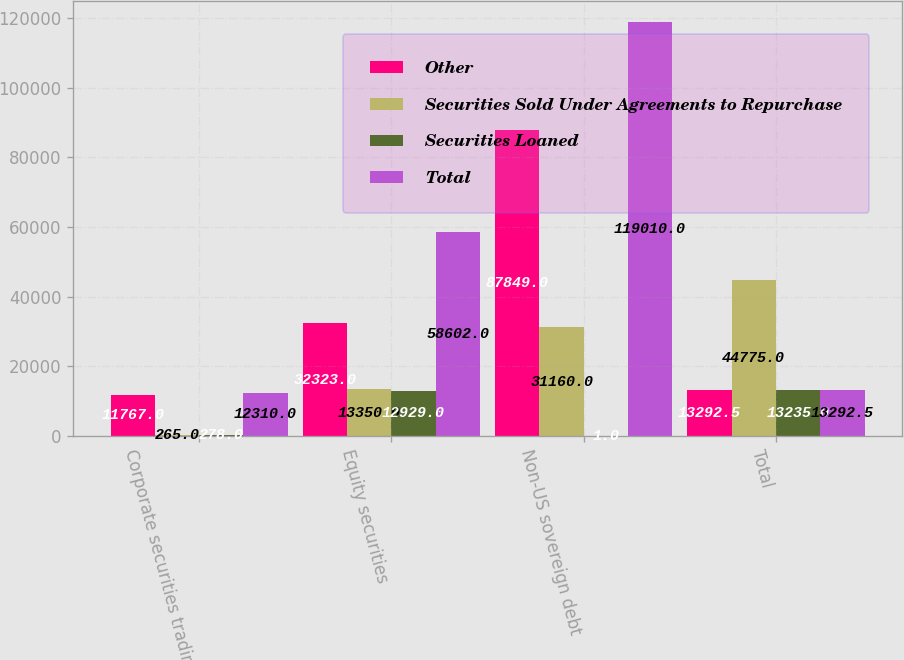Convert chart to OTSL. <chart><loc_0><loc_0><loc_500><loc_500><stacked_bar_chart><ecel><fcel>Corporate securities trading<fcel>Equity securities<fcel>Non-US sovereign debt<fcel>Total<nl><fcel>Other<fcel>11767<fcel>32323<fcel>87849<fcel>13292.5<nl><fcel>Securities Sold Under Agreements to Repurchase<fcel>265<fcel>13350<fcel>31160<fcel>44775<nl><fcel>Securities Loaned<fcel>278<fcel>12929<fcel>1<fcel>13235<nl><fcel>Total<fcel>12310<fcel>58602<fcel>119010<fcel>13292.5<nl></chart> 